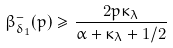<formula> <loc_0><loc_0><loc_500><loc_500>\beta ^ { - } _ { \delta _ { 1 } } ( p ) \geq \frac { 2 p \kappa _ { \lambda } } { \alpha + \kappa _ { \lambda } + 1 / 2 }</formula> 